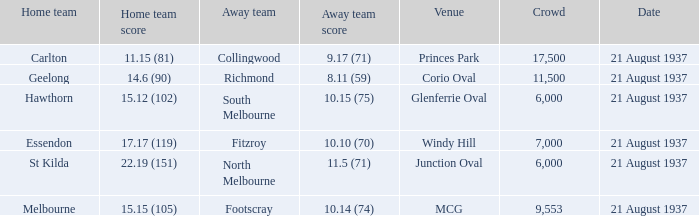Where was richmond's playing location? Corio Oval. 